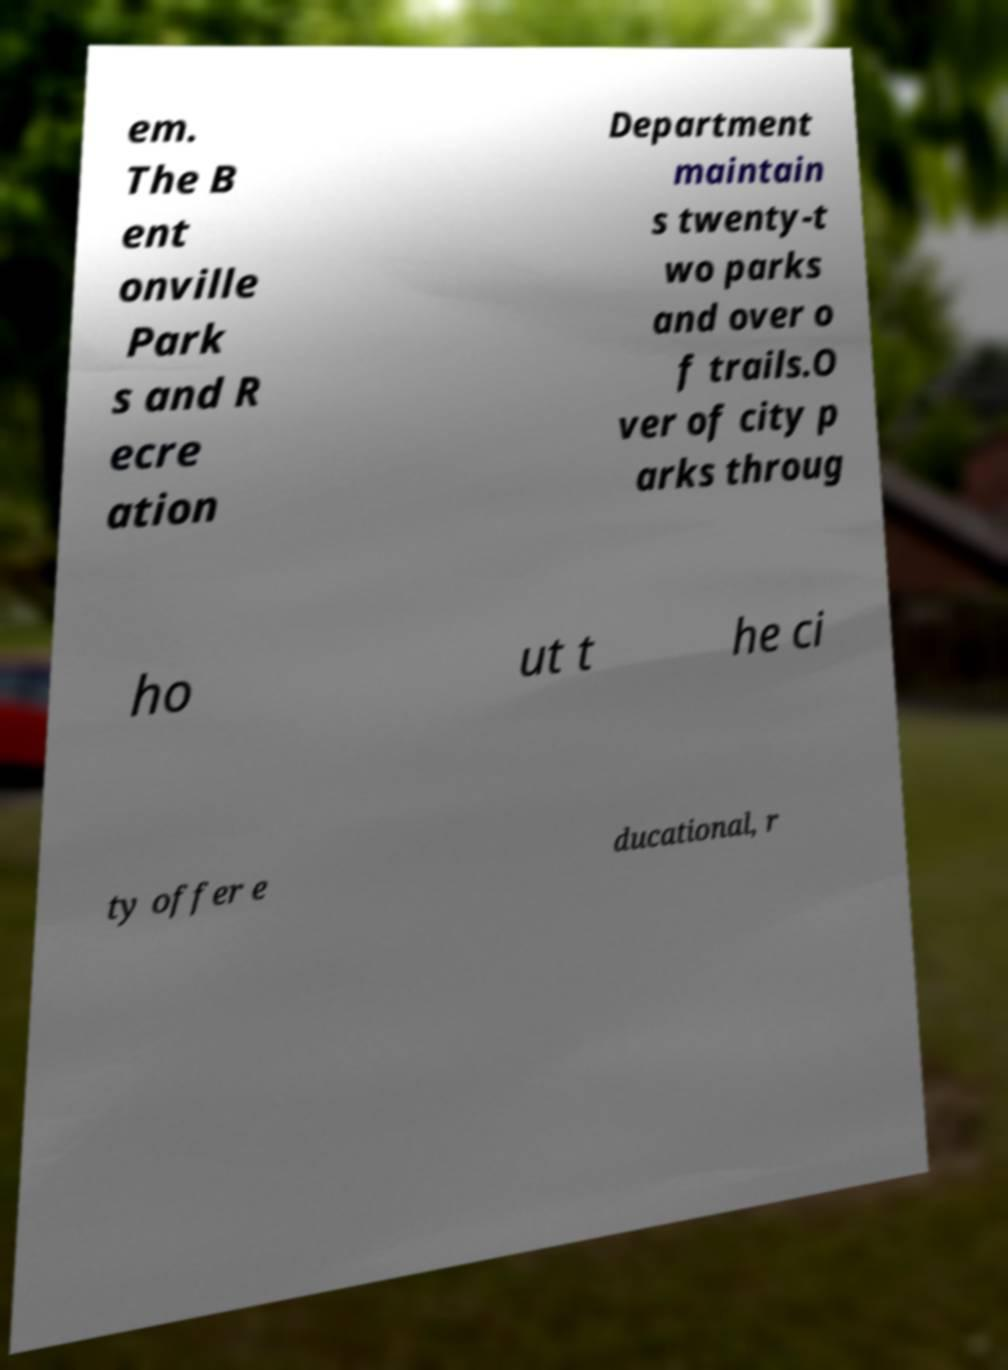Can you accurately transcribe the text from the provided image for me? em. The B ent onville Park s and R ecre ation Department maintain s twenty-t wo parks and over o f trails.O ver of city p arks throug ho ut t he ci ty offer e ducational, r 